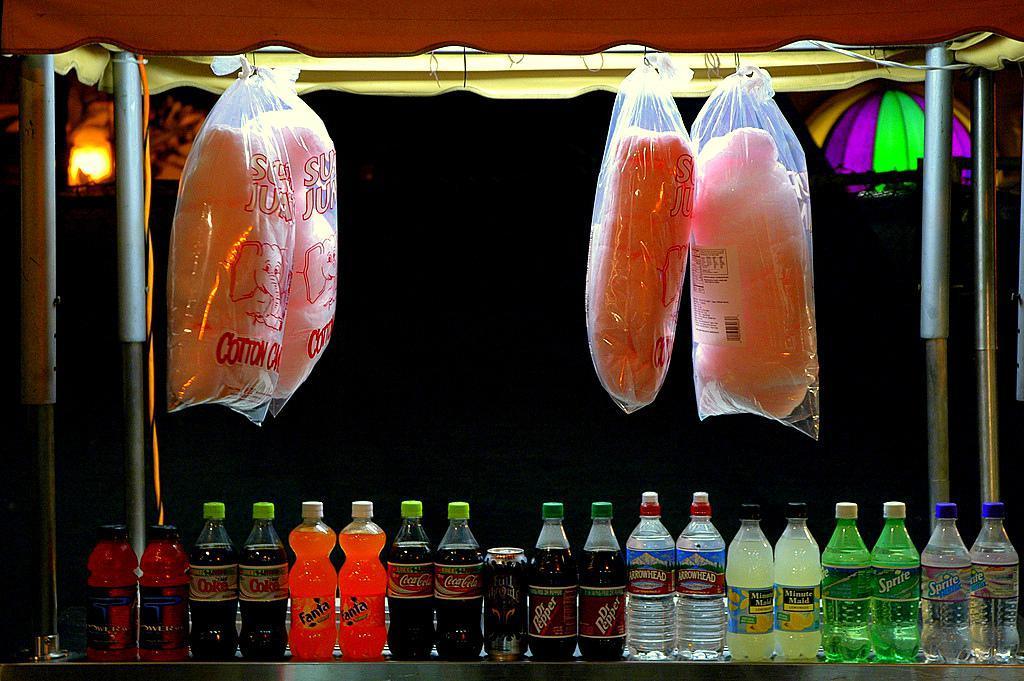In one or two sentences, can you explain what this image depicts? In this image I can see bottles,tin and some covers. In the background there is a light. 